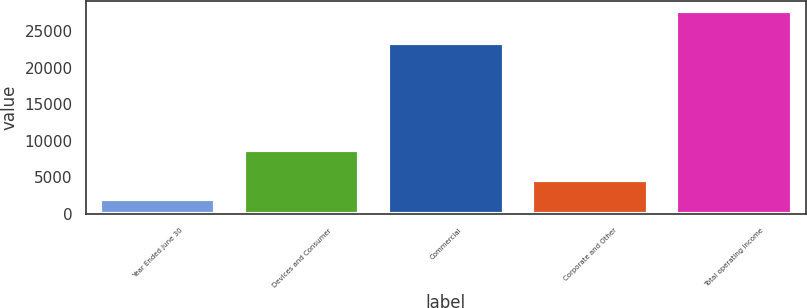Convert chart to OTSL. <chart><loc_0><loc_0><loc_500><loc_500><bar_chart><fcel>Year Ended June 30<fcel>Devices and Consumer<fcel>Commercial<fcel>Corporate and Other<fcel>Total operating income<nl><fcel>2014<fcel>8714<fcel>23467<fcel>4588.5<fcel>27759<nl></chart> 